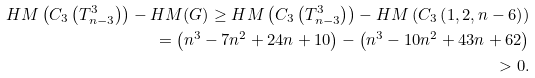<formula> <loc_0><loc_0><loc_500><loc_500>H M \left ( C _ { 3 } \left ( T ^ { 3 } _ { n - 3 } \right ) \right ) - H M ( G ) \geq H M \left ( C _ { 3 } \left ( T ^ { 3 } _ { n - 3 } \right ) \right ) - H M \left ( C _ { 3 } \left ( 1 , 2 , n - 6 \right ) \right ) \\ = \left ( n ^ { 3 } - 7 n ^ { 2 } + 2 4 n + 1 0 \right ) - \left ( n ^ { 3 } - 1 0 n ^ { 2 } + 4 3 n + 6 2 \right ) \\ > 0 .</formula> 